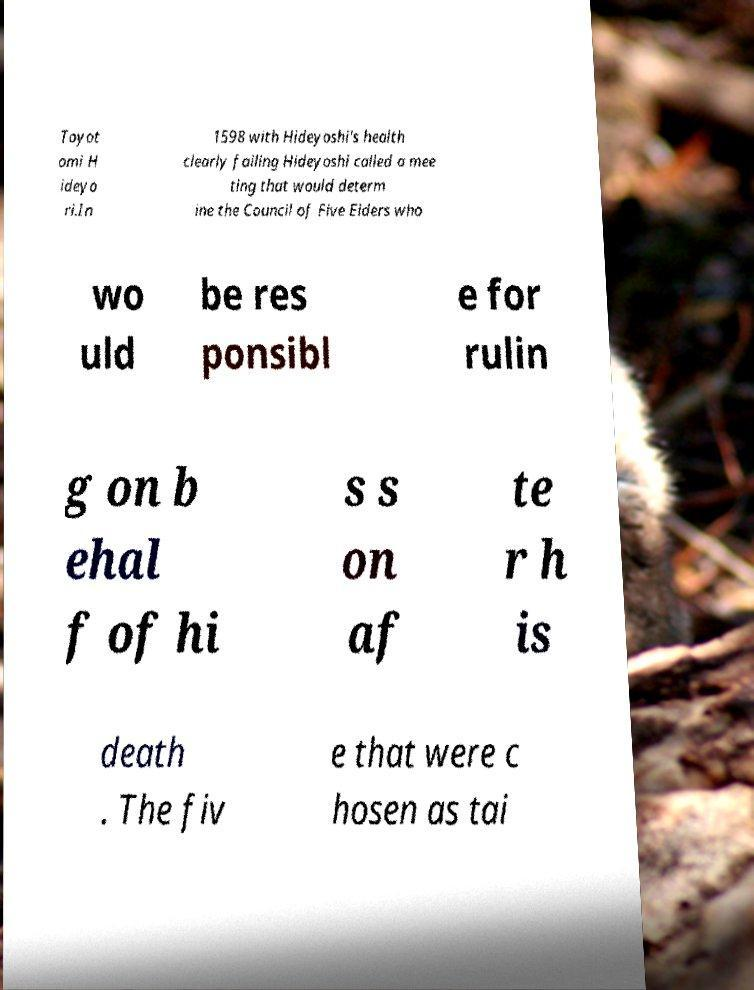Please read and relay the text visible in this image. What does it say? Toyot omi H ideyo ri.In 1598 with Hideyoshi's health clearly failing Hideyoshi called a mee ting that would determ ine the Council of Five Elders who wo uld be res ponsibl e for rulin g on b ehal f of hi s s on af te r h is death . The fiv e that were c hosen as tai 